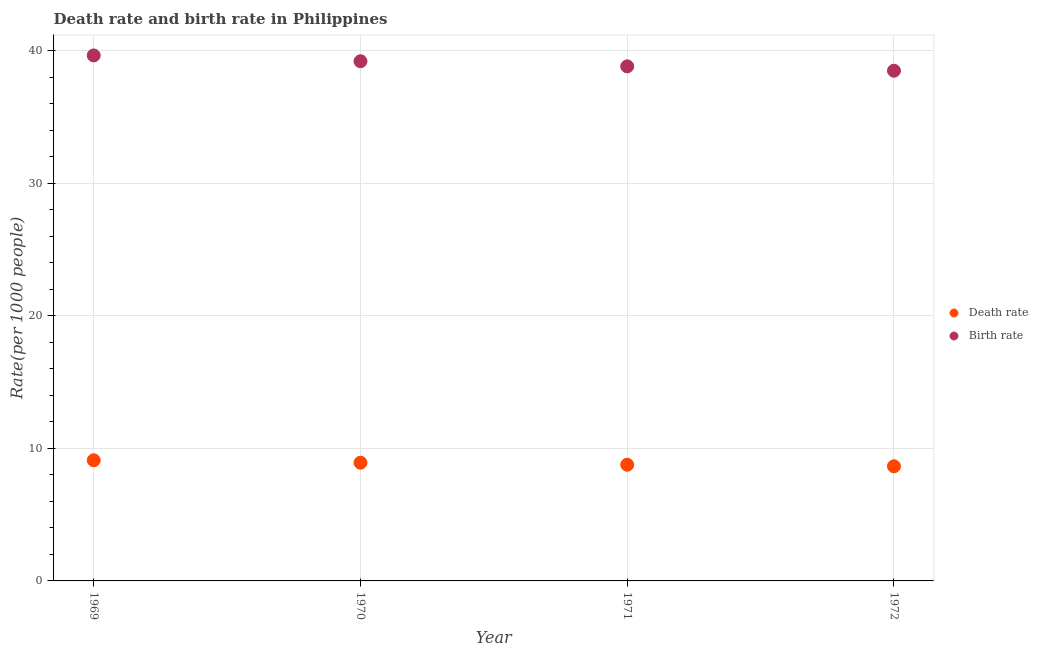What is the death rate in 1970?
Make the answer very short. 8.92. Across all years, what is the minimum birth rate?
Give a very brief answer. 38.48. In which year was the death rate maximum?
Provide a short and direct response. 1969. What is the total death rate in the graph?
Offer a terse response. 35.43. What is the difference between the birth rate in 1971 and that in 1972?
Ensure brevity in your answer.  0.33. What is the difference between the birth rate in 1972 and the death rate in 1969?
Provide a short and direct response. 29.38. What is the average birth rate per year?
Your response must be concise. 39.03. In the year 1972, what is the difference between the death rate and birth rate?
Your answer should be compact. -29.84. What is the ratio of the birth rate in 1969 to that in 1972?
Make the answer very short. 1.03. Is the birth rate in 1969 less than that in 1972?
Your answer should be very brief. No. Is the difference between the death rate in 1971 and 1972 greater than the difference between the birth rate in 1971 and 1972?
Provide a short and direct response. No. What is the difference between the highest and the second highest birth rate?
Your response must be concise. 0.44. What is the difference between the highest and the lowest death rate?
Your response must be concise. 0.45. In how many years, is the death rate greater than the average death rate taken over all years?
Keep it short and to the point. 2. How many dotlines are there?
Keep it short and to the point. 2. Are the values on the major ticks of Y-axis written in scientific E-notation?
Ensure brevity in your answer.  No. Does the graph contain any zero values?
Provide a short and direct response. No. Does the graph contain grids?
Make the answer very short. Yes. How many legend labels are there?
Keep it short and to the point. 2. What is the title of the graph?
Make the answer very short. Death rate and birth rate in Philippines. Does "Crop" appear as one of the legend labels in the graph?
Provide a short and direct response. No. What is the label or title of the Y-axis?
Offer a terse response. Rate(per 1000 people). What is the Rate(per 1000 people) in Birth rate in 1969?
Offer a very short reply. 39.64. What is the Rate(per 1000 people) in Death rate in 1970?
Offer a terse response. 8.92. What is the Rate(per 1000 people) in Birth rate in 1970?
Your answer should be very brief. 39.2. What is the Rate(per 1000 people) in Death rate in 1971?
Give a very brief answer. 8.76. What is the Rate(per 1000 people) of Birth rate in 1971?
Provide a short and direct response. 38.81. What is the Rate(per 1000 people) in Death rate in 1972?
Keep it short and to the point. 8.65. What is the Rate(per 1000 people) in Birth rate in 1972?
Offer a terse response. 38.48. Across all years, what is the maximum Rate(per 1000 people) in Death rate?
Your answer should be compact. 9.1. Across all years, what is the maximum Rate(per 1000 people) in Birth rate?
Offer a very short reply. 39.64. Across all years, what is the minimum Rate(per 1000 people) of Death rate?
Keep it short and to the point. 8.65. Across all years, what is the minimum Rate(per 1000 people) in Birth rate?
Give a very brief answer. 38.48. What is the total Rate(per 1000 people) of Death rate in the graph?
Your answer should be compact. 35.43. What is the total Rate(per 1000 people) in Birth rate in the graph?
Provide a short and direct response. 156.13. What is the difference between the Rate(per 1000 people) in Death rate in 1969 and that in 1970?
Offer a terse response. 0.18. What is the difference between the Rate(per 1000 people) of Birth rate in 1969 and that in 1970?
Provide a succinct answer. 0.44. What is the difference between the Rate(per 1000 people) of Death rate in 1969 and that in 1971?
Your answer should be compact. 0.34. What is the difference between the Rate(per 1000 people) of Birth rate in 1969 and that in 1971?
Make the answer very short. 0.82. What is the difference between the Rate(per 1000 people) in Death rate in 1969 and that in 1972?
Your answer should be compact. 0.45. What is the difference between the Rate(per 1000 people) in Birth rate in 1969 and that in 1972?
Keep it short and to the point. 1.15. What is the difference between the Rate(per 1000 people) in Death rate in 1970 and that in 1971?
Your response must be concise. 0.15. What is the difference between the Rate(per 1000 people) of Birth rate in 1970 and that in 1971?
Provide a succinct answer. 0.39. What is the difference between the Rate(per 1000 people) of Death rate in 1970 and that in 1972?
Your answer should be compact. 0.27. What is the difference between the Rate(per 1000 people) in Birth rate in 1970 and that in 1972?
Your answer should be very brief. 0.71. What is the difference between the Rate(per 1000 people) of Death rate in 1971 and that in 1972?
Offer a very short reply. 0.12. What is the difference between the Rate(per 1000 people) in Birth rate in 1971 and that in 1972?
Make the answer very short. 0.33. What is the difference between the Rate(per 1000 people) in Death rate in 1969 and the Rate(per 1000 people) in Birth rate in 1970?
Keep it short and to the point. -30.1. What is the difference between the Rate(per 1000 people) in Death rate in 1969 and the Rate(per 1000 people) in Birth rate in 1971?
Offer a very short reply. -29.71. What is the difference between the Rate(per 1000 people) in Death rate in 1969 and the Rate(per 1000 people) in Birth rate in 1972?
Provide a short and direct response. -29.38. What is the difference between the Rate(per 1000 people) in Death rate in 1970 and the Rate(per 1000 people) in Birth rate in 1971?
Offer a very short reply. -29.89. What is the difference between the Rate(per 1000 people) of Death rate in 1970 and the Rate(per 1000 people) of Birth rate in 1972?
Ensure brevity in your answer.  -29.57. What is the difference between the Rate(per 1000 people) in Death rate in 1971 and the Rate(per 1000 people) in Birth rate in 1972?
Your answer should be very brief. -29.72. What is the average Rate(per 1000 people) of Death rate per year?
Offer a very short reply. 8.86. What is the average Rate(per 1000 people) of Birth rate per year?
Ensure brevity in your answer.  39.03. In the year 1969, what is the difference between the Rate(per 1000 people) of Death rate and Rate(per 1000 people) of Birth rate?
Offer a terse response. -30.54. In the year 1970, what is the difference between the Rate(per 1000 people) of Death rate and Rate(per 1000 people) of Birth rate?
Provide a short and direct response. -30.28. In the year 1971, what is the difference between the Rate(per 1000 people) of Death rate and Rate(per 1000 people) of Birth rate?
Your response must be concise. -30.05. In the year 1972, what is the difference between the Rate(per 1000 people) in Death rate and Rate(per 1000 people) in Birth rate?
Give a very brief answer. -29.84. What is the ratio of the Rate(per 1000 people) of Death rate in 1969 to that in 1970?
Give a very brief answer. 1.02. What is the ratio of the Rate(per 1000 people) of Birth rate in 1969 to that in 1970?
Your answer should be compact. 1.01. What is the ratio of the Rate(per 1000 people) in Death rate in 1969 to that in 1971?
Provide a short and direct response. 1.04. What is the ratio of the Rate(per 1000 people) of Birth rate in 1969 to that in 1971?
Provide a short and direct response. 1.02. What is the ratio of the Rate(per 1000 people) of Death rate in 1969 to that in 1972?
Give a very brief answer. 1.05. What is the ratio of the Rate(per 1000 people) of Birth rate in 1969 to that in 1972?
Your response must be concise. 1.03. What is the ratio of the Rate(per 1000 people) of Death rate in 1970 to that in 1971?
Your response must be concise. 1.02. What is the ratio of the Rate(per 1000 people) in Birth rate in 1970 to that in 1971?
Your answer should be very brief. 1.01. What is the ratio of the Rate(per 1000 people) of Death rate in 1970 to that in 1972?
Provide a short and direct response. 1.03. What is the ratio of the Rate(per 1000 people) in Birth rate in 1970 to that in 1972?
Provide a succinct answer. 1.02. What is the ratio of the Rate(per 1000 people) in Death rate in 1971 to that in 1972?
Keep it short and to the point. 1.01. What is the ratio of the Rate(per 1000 people) in Birth rate in 1971 to that in 1972?
Offer a very short reply. 1.01. What is the difference between the highest and the second highest Rate(per 1000 people) of Death rate?
Your response must be concise. 0.18. What is the difference between the highest and the second highest Rate(per 1000 people) in Birth rate?
Your answer should be very brief. 0.44. What is the difference between the highest and the lowest Rate(per 1000 people) of Death rate?
Offer a very short reply. 0.45. What is the difference between the highest and the lowest Rate(per 1000 people) in Birth rate?
Provide a short and direct response. 1.15. 